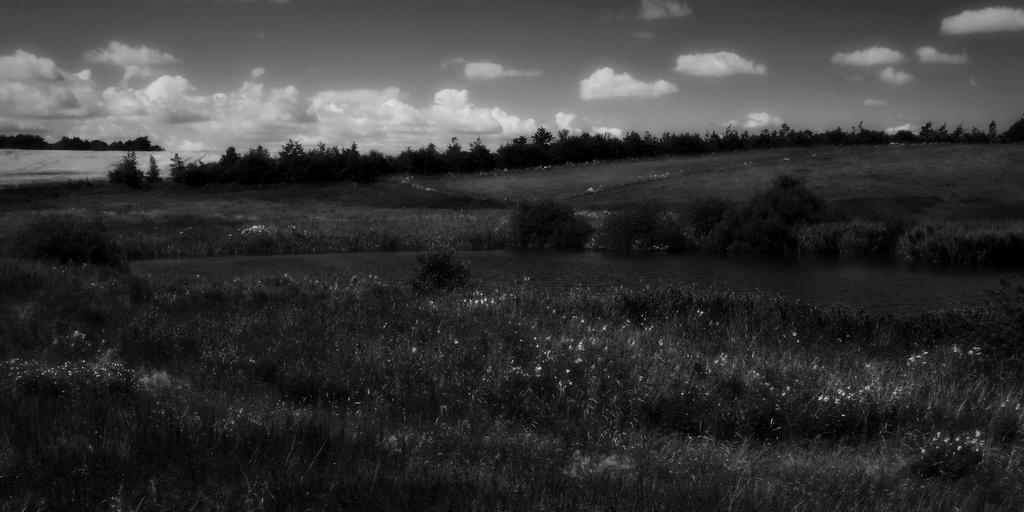Please provide a concise description of this image. It looks like a black and white picture. We can see there are plants on the path and behind the plants there are trees and a cloudy sky. 